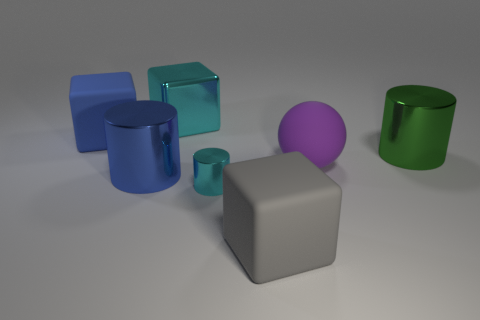Subtract all cyan cylinders. How many cylinders are left? 2 Subtract all matte blocks. How many blocks are left? 1 Subtract 0 purple cubes. How many objects are left? 7 Subtract all cylinders. How many objects are left? 4 Subtract 1 balls. How many balls are left? 0 Subtract all gray cylinders. Subtract all blue cubes. How many cylinders are left? 3 Subtract all gray spheres. How many cyan cylinders are left? 1 Subtract all big yellow matte cylinders. Subtract all large matte spheres. How many objects are left? 6 Add 7 green metal things. How many green metal things are left? 8 Add 1 large blue matte cylinders. How many large blue matte cylinders exist? 1 